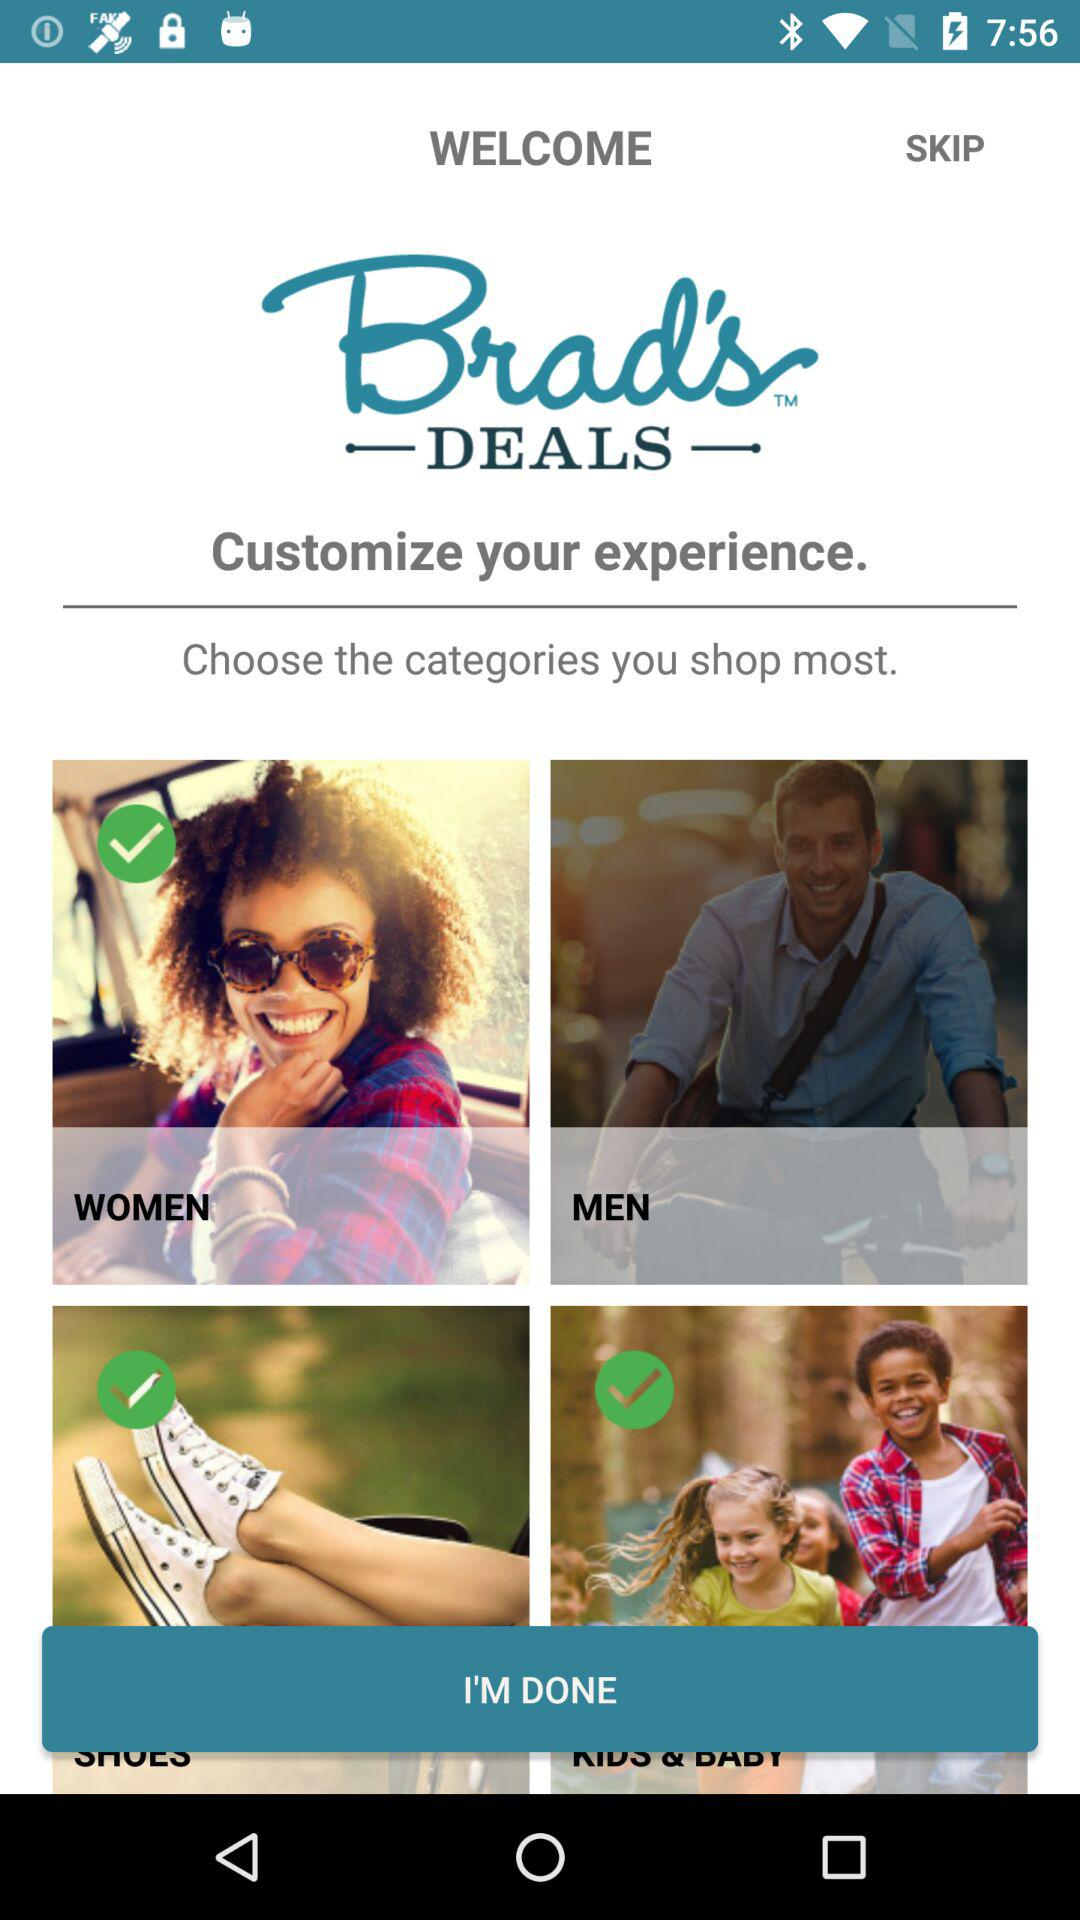How many categories are there in total?
Answer the question using a single word or phrase. 4 